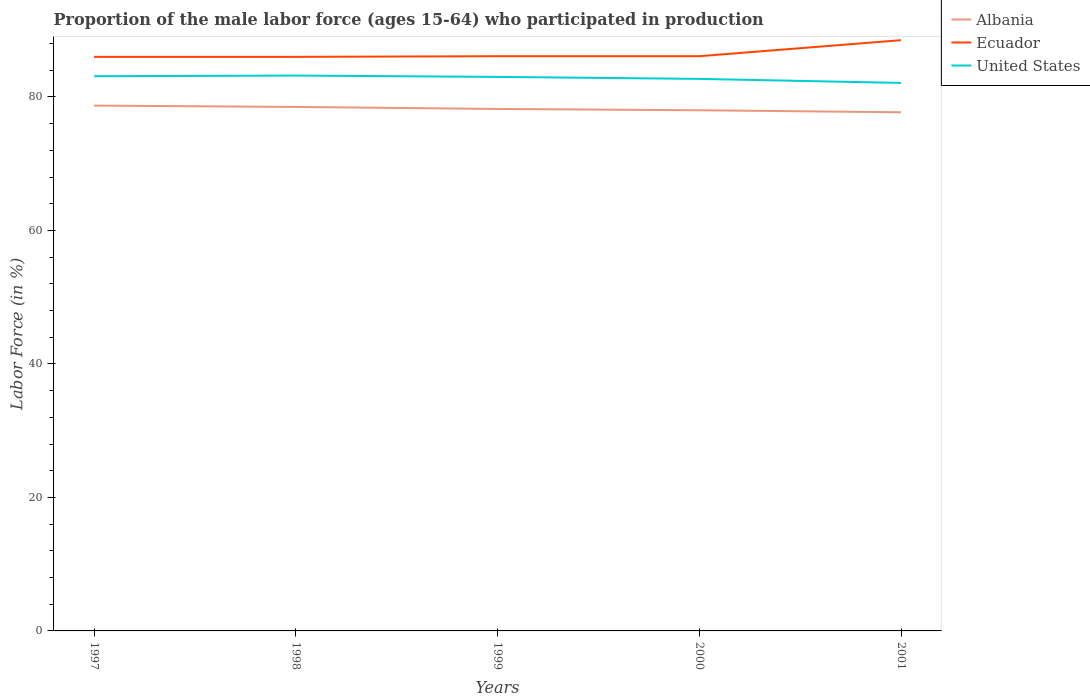Is the number of lines equal to the number of legend labels?
Provide a succinct answer. Yes. Across all years, what is the maximum proportion of the male labor force who participated in production in Albania?
Give a very brief answer. 77.7. What is the total proportion of the male labor force who participated in production in Ecuador in the graph?
Provide a succinct answer. -2.5. Is the proportion of the male labor force who participated in production in Albania strictly greater than the proportion of the male labor force who participated in production in Ecuador over the years?
Keep it short and to the point. Yes. What is the difference between two consecutive major ticks on the Y-axis?
Keep it short and to the point. 20. Are the values on the major ticks of Y-axis written in scientific E-notation?
Offer a terse response. No. Does the graph contain any zero values?
Offer a very short reply. No. What is the title of the graph?
Give a very brief answer. Proportion of the male labor force (ages 15-64) who participated in production. What is the Labor Force (in %) of Albania in 1997?
Offer a very short reply. 78.7. What is the Labor Force (in %) in United States in 1997?
Make the answer very short. 83.1. What is the Labor Force (in %) in Albania in 1998?
Provide a succinct answer. 78.5. What is the Labor Force (in %) in Ecuador in 1998?
Provide a succinct answer. 86. What is the Labor Force (in %) of United States in 1998?
Provide a succinct answer. 83.2. What is the Labor Force (in %) of Albania in 1999?
Your response must be concise. 78.2. What is the Labor Force (in %) in Ecuador in 1999?
Keep it short and to the point. 86.1. What is the Labor Force (in %) of Ecuador in 2000?
Provide a short and direct response. 86.1. What is the Labor Force (in %) in United States in 2000?
Provide a short and direct response. 82.7. What is the Labor Force (in %) in Albania in 2001?
Your response must be concise. 77.7. What is the Labor Force (in %) in Ecuador in 2001?
Ensure brevity in your answer.  88.5. What is the Labor Force (in %) in United States in 2001?
Offer a very short reply. 82.1. Across all years, what is the maximum Labor Force (in %) in Albania?
Keep it short and to the point. 78.7. Across all years, what is the maximum Labor Force (in %) of Ecuador?
Make the answer very short. 88.5. Across all years, what is the maximum Labor Force (in %) of United States?
Your answer should be very brief. 83.2. Across all years, what is the minimum Labor Force (in %) in Albania?
Your response must be concise. 77.7. Across all years, what is the minimum Labor Force (in %) of United States?
Your response must be concise. 82.1. What is the total Labor Force (in %) in Albania in the graph?
Provide a succinct answer. 391.1. What is the total Labor Force (in %) in Ecuador in the graph?
Keep it short and to the point. 432.7. What is the total Labor Force (in %) of United States in the graph?
Your answer should be compact. 414.1. What is the difference between the Labor Force (in %) of Ecuador in 1997 and that in 2000?
Give a very brief answer. -0.1. What is the difference between the Labor Force (in %) in United States in 1997 and that in 2000?
Your answer should be compact. 0.4. What is the difference between the Labor Force (in %) of United States in 1997 and that in 2001?
Provide a succinct answer. 1. What is the difference between the Labor Force (in %) of Albania in 1998 and that in 1999?
Provide a short and direct response. 0.3. What is the difference between the Labor Force (in %) in Ecuador in 1998 and that in 2000?
Your answer should be very brief. -0.1. What is the difference between the Labor Force (in %) of Ecuador in 1998 and that in 2001?
Your response must be concise. -2.5. What is the difference between the Labor Force (in %) of United States in 1998 and that in 2001?
Provide a short and direct response. 1.1. What is the difference between the Labor Force (in %) in United States in 1999 and that in 2000?
Your answer should be very brief. 0.3. What is the difference between the Labor Force (in %) of Albania in 2000 and that in 2001?
Offer a very short reply. 0.3. What is the difference between the Labor Force (in %) of United States in 2000 and that in 2001?
Offer a very short reply. 0.6. What is the difference between the Labor Force (in %) of Albania in 1997 and the Labor Force (in %) of Ecuador in 1999?
Your answer should be very brief. -7.4. What is the difference between the Labor Force (in %) in Albania in 1997 and the Labor Force (in %) in United States in 1999?
Provide a short and direct response. -4.3. What is the difference between the Labor Force (in %) of Ecuador in 1997 and the Labor Force (in %) of United States in 1999?
Provide a succinct answer. 3. What is the difference between the Labor Force (in %) in Albania in 1997 and the Labor Force (in %) in Ecuador in 2000?
Offer a terse response. -7.4. What is the difference between the Labor Force (in %) in Ecuador in 1997 and the Labor Force (in %) in United States in 2000?
Provide a succinct answer. 3.3. What is the difference between the Labor Force (in %) in Albania in 1997 and the Labor Force (in %) in United States in 2001?
Ensure brevity in your answer.  -3.4. What is the difference between the Labor Force (in %) in Albania in 1998 and the Labor Force (in %) in United States in 1999?
Provide a short and direct response. -4.5. What is the difference between the Labor Force (in %) in Albania in 1998 and the Labor Force (in %) in Ecuador in 2000?
Provide a short and direct response. -7.6. What is the difference between the Labor Force (in %) in Albania in 1998 and the Labor Force (in %) in United States in 2000?
Offer a terse response. -4.2. What is the difference between the Labor Force (in %) of Ecuador in 1998 and the Labor Force (in %) of United States in 2000?
Your answer should be very brief. 3.3. What is the difference between the Labor Force (in %) in Ecuador in 1999 and the Labor Force (in %) in United States in 2000?
Make the answer very short. 3.4. What is the difference between the Labor Force (in %) of Albania in 1999 and the Labor Force (in %) of Ecuador in 2001?
Provide a short and direct response. -10.3. What is the difference between the Labor Force (in %) of Albania in 2000 and the Labor Force (in %) of United States in 2001?
Provide a succinct answer. -4.1. What is the average Labor Force (in %) of Albania per year?
Provide a succinct answer. 78.22. What is the average Labor Force (in %) in Ecuador per year?
Keep it short and to the point. 86.54. What is the average Labor Force (in %) of United States per year?
Keep it short and to the point. 82.82. In the year 1997, what is the difference between the Labor Force (in %) of Albania and Labor Force (in %) of Ecuador?
Keep it short and to the point. -7.3. In the year 1998, what is the difference between the Labor Force (in %) in Albania and Labor Force (in %) in Ecuador?
Your answer should be very brief. -7.5. In the year 1999, what is the difference between the Labor Force (in %) of Albania and Labor Force (in %) of Ecuador?
Ensure brevity in your answer.  -7.9. In the year 2000, what is the difference between the Labor Force (in %) of Ecuador and Labor Force (in %) of United States?
Provide a short and direct response. 3.4. In the year 2001, what is the difference between the Labor Force (in %) in Albania and Labor Force (in %) in United States?
Your answer should be very brief. -4.4. What is the ratio of the Labor Force (in %) in United States in 1997 to that in 1998?
Provide a short and direct response. 1. What is the ratio of the Labor Force (in %) in Albania in 1997 to that in 1999?
Your answer should be very brief. 1.01. What is the ratio of the Labor Force (in %) in Ecuador in 1997 to that in 1999?
Give a very brief answer. 1. What is the ratio of the Labor Force (in %) of Ecuador in 1997 to that in 2000?
Give a very brief answer. 1. What is the ratio of the Labor Force (in %) of Albania in 1997 to that in 2001?
Provide a succinct answer. 1.01. What is the ratio of the Labor Force (in %) in Ecuador in 1997 to that in 2001?
Give a very brief answer. 0.97. What is the ratio of the Labor Force (in %) of United States in 1997 to that in 2001?
Ensure brevity in your answer.  1.01. What is the ratio of the Labor Force (in %) of Albania in 1998 to that in 1999?
Your answer should be very brief. 1. What is the ratio of the Labor Force (in %) of United States in 1998 to that in 1999?
Your response must be concise. 1. What is the ratio of the Labor Force (in %) of Albania in 1998 to that in 2000?
Provide a succinct answer. 1.01. What is the ratio of the Labor Force (in %) of Albania in 1998 to that in 2001?
Your response must be concise. 1.01. What is the ratio of the Labor Force (in %) of Ecuador in 1998 to that in 2001?
Your answer should be very brief. 0.97. What is the ratio of the Labor Force (in %) in United States in 1998 to that in 2001?
Give a very brief answer. 1.01. What is the ratio of the Labor Force (in %) in Ecuador in 1999 to that in 2000?
Your answer should be very brief. 1. What is the ratio of the Labor Force (in %) in Albania in 1999 to that in 2001?
Give a very brief answer. 1.01. What is the ratio of the Labor Force (in %) of Ecuador in 1999 to that in 2001?
Offer a very short reply. 0.97. What is the ratio of the Labor Force (in %) of United States in 1999 to that in 2001?
Provide a succinct answer. 1.01. What is the ratio of the Labor Force (in %) in Ecuador in 2000 to that in 2001?
Ensure brevity in your answer.  0.97. What is the ratio of the Labor Force (in %) of United States in 2000 to that in 2001?
Your answer should be compact. 1.01. What is the difference between the highest and the second highest Labor Force (in %) of United States?
Your answer should be compact. 0.1. What is the difference between the highest and the lowest Labor Force (in %) of Ecuador?
Provide a succinct answer. 2.5. What is the difference between the highest and the lowest Labor Force (in %) in United States?
Ensure brevity in your answer.  1.1. 